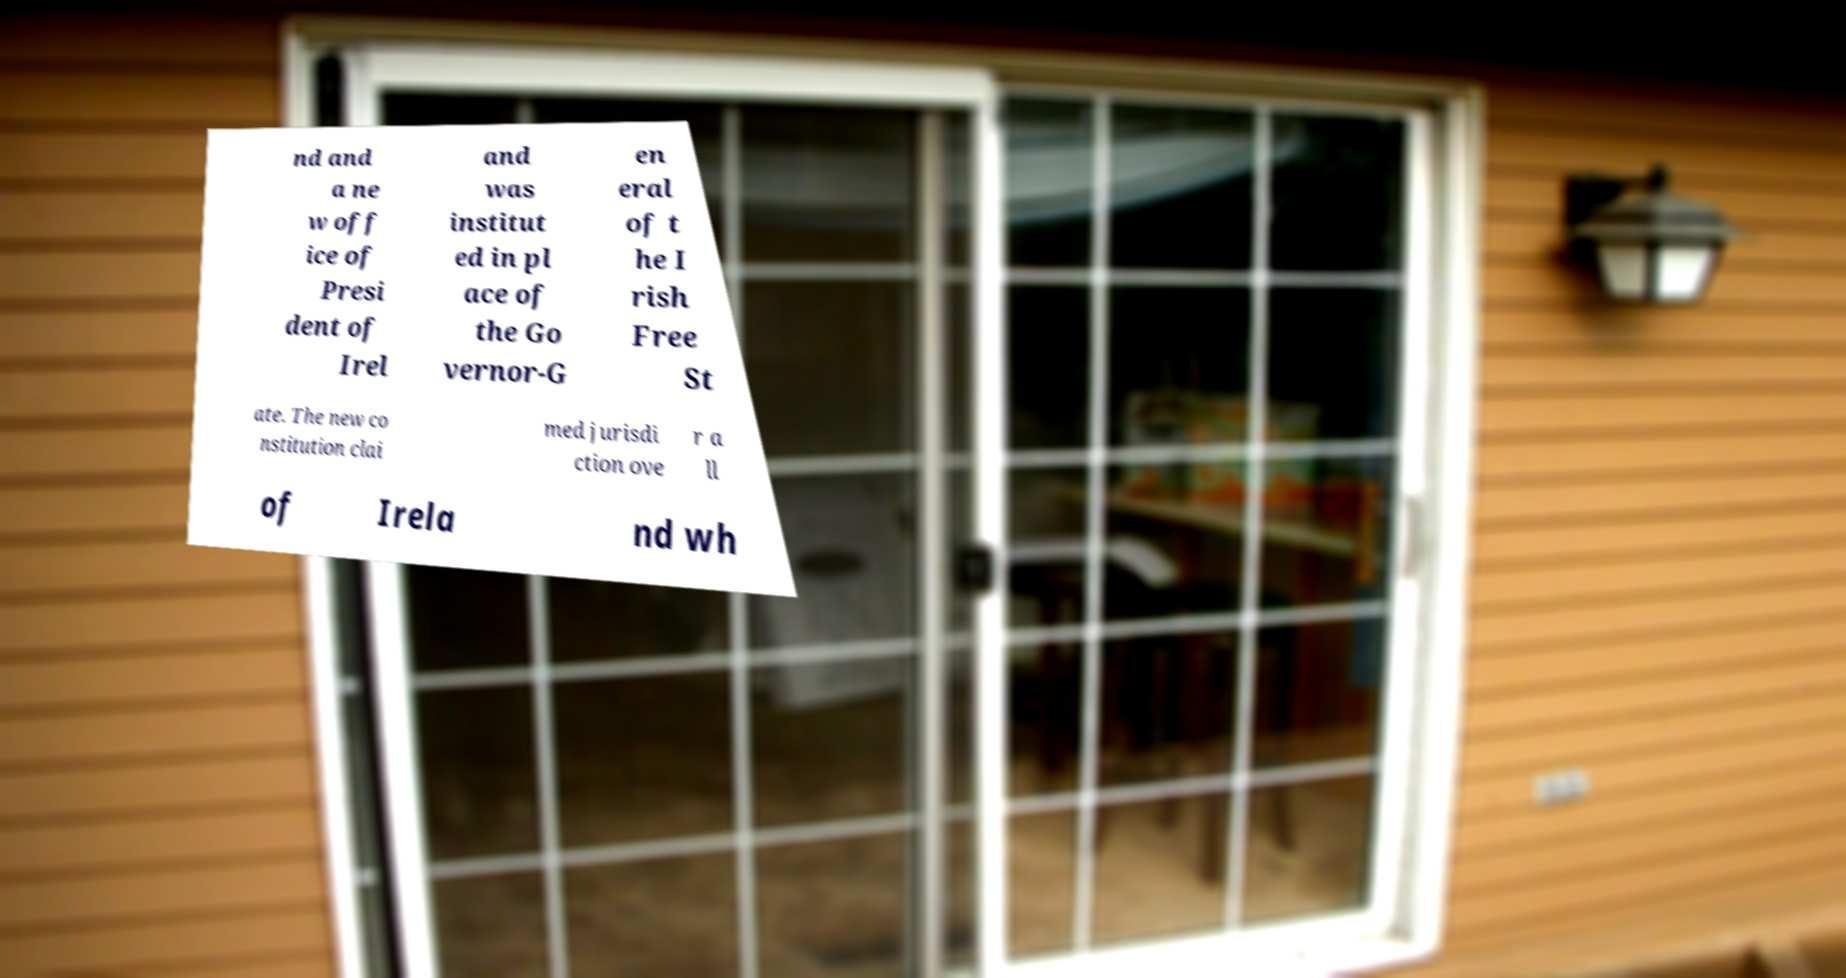Please read and relay the text visible in this image. What does it say? nd and a ne w off ice of Presi dent of Irel and was institut ed in pl ace of the Go vernor-G en eral of t he I rish Free St ate. The new co nstitution clai med jurisdi ction ove r a ll of Irela nd wh 